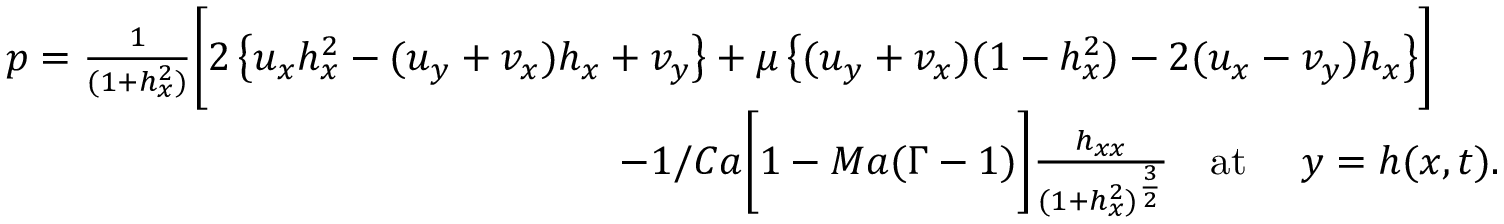<formula> <loc_0><loc_0><loc_500><loc_500>\begin{array} { r l } & { p = \frac { 1 } { ( 1 + h _ { x } ^ { 2 } ) } \left [ 2 \left \{ u _ { x } h _ { x } ^ { 2 } - ( u _ { y } + v _ { x } ) h _ { x } + v _ { y } \right \} + \mu \left \{ ( u _ { y } + v _ { x } ) ( 1 - h _ { x } ^ { 2 } ) - 2 ( u _ { x } - v _ { y } ) h _ { x } \right \} \right ] } \\ & { - 1 / C a \left [ 1 - M a ( \Gamma - 1 ) \right ] \frac { h _ { x x } } { ( 1 + h _ { x } ^ { 2 } ) ^ { \frac { 3 } { 2 } } } a t y = h ( x , t ) . } \end{array}</formula> 